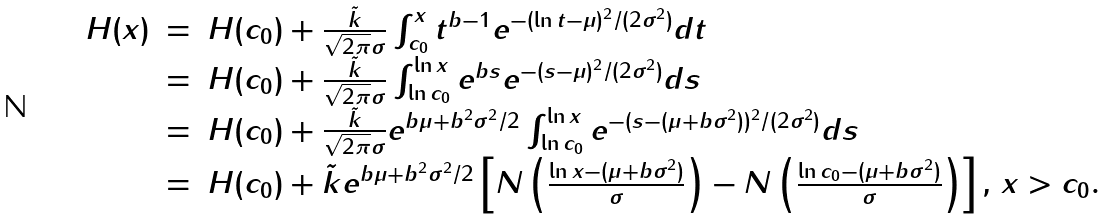Convert formula to latex. <formula><loc_0><loc_0><loc_500><loc_500>\begin{array} { r c l } H ( x ) & = & H ( c _ { 0 } ) + \frac { \tilde { k } } { \sqrt { 2 \pi } \sigma } \int _ { c _ { 0 } } ^ { x } t ^ { b - 1 } e ^ { - ( \ln t - \mu ) ^ { 2 } / ( 2 \sigma ^ { 2 } ) } d t \\ & = & H ( c _ { 0 } ) + \frac { \tilde { k } } { \sqrt { 2 \pi } \sigma } \int _ { \ln c _ { 0 } } ^ { \ln x } e ^ { b s } e ^ { - ( s - \mu ) ^ { 2 } / ( 2 \sigma ^ { 2 } ) } d s \\ & = & H ( c _ { 0 } ) + \frac { \tilde { k } } { \sqrt { 2 \pi } \sigma } e ^ { b \mu + b ^ { 2 } \sigma ^ { 2 } / 2 } \int _ { \ln c _ { 0 } } ^ { \ln x } e ^ { - ( s - ( \mu + b \sigma ^ { 2 } ) ) ^ { 2 } / ( 2 \sigma ^ { 2 } ) } d s \\ & = & H ( c _ { 0 } ) + \tilde { k } e ^ { b \mu + b ^ { 2 } \sigma ^ { 2 } / 2 } \left [ N \left ( \frac { \ln x - ( \mu + b \sigma ^ { 2 } ) } { \sigma } \right ) - N \left ( \frac { \ln c _ { 0 } - ( \mu + b \sigma ^ { 2 } ) } { \sigma } \right ) \right ] , \, x > c _ { 0 } . \end{array}</formula> 